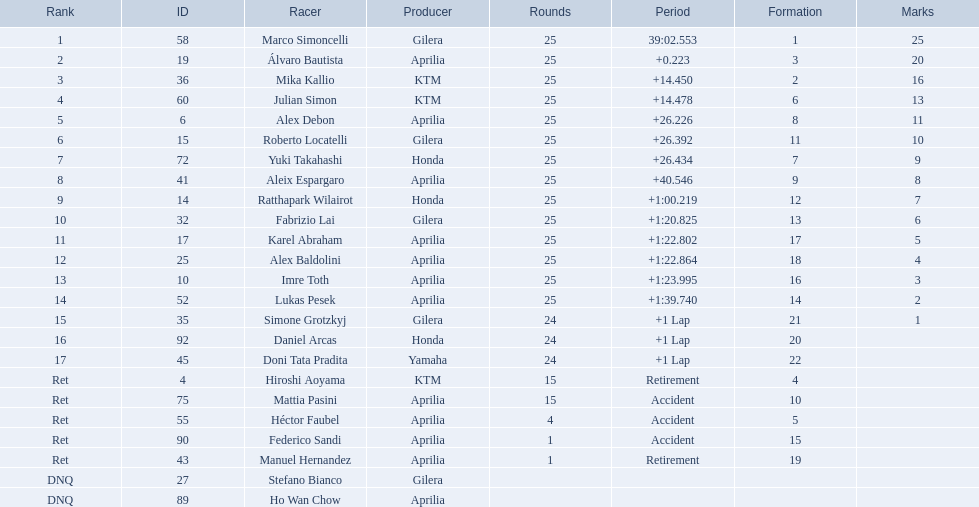How many laps did marco perform? 25. How many laps did hiroshi perform? 15. Which of these numbers are higher? 25. Who swam this number of laps? Marco Simoncelli. 